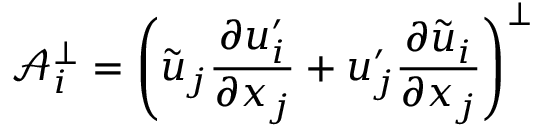Convert formula to latex. <formula><loc_0><loc_0><loc_500><loc_500>\mathcal { A } _ { i } ^ { \bot } = \left ( \tilde { u } _ { j } \frac { \partial u _ { i } ^ { \prime } } { \partial x _ { j } } + u _ { j } ^ { \prime } \frac { \partial \tilde { u } _ { i } } { \partial x _ { j } } \right ) ^ { \bot }</formula> 